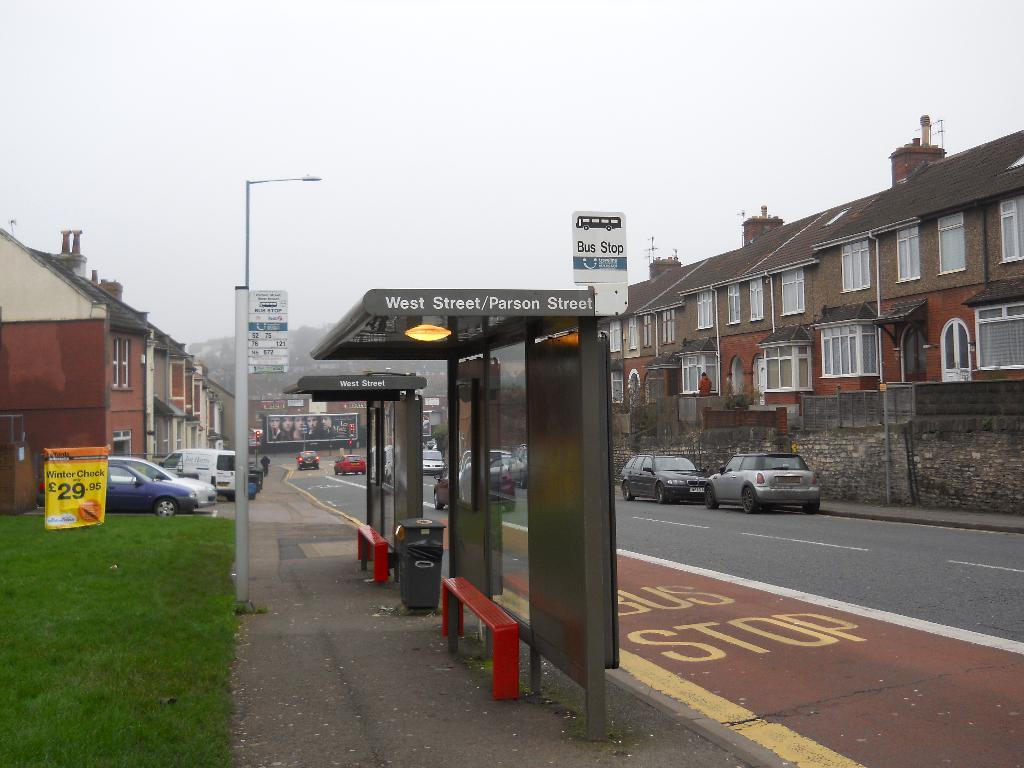<image>
Provide a brief description of the given image. The West Street / Parson Street bus stop shelter. 